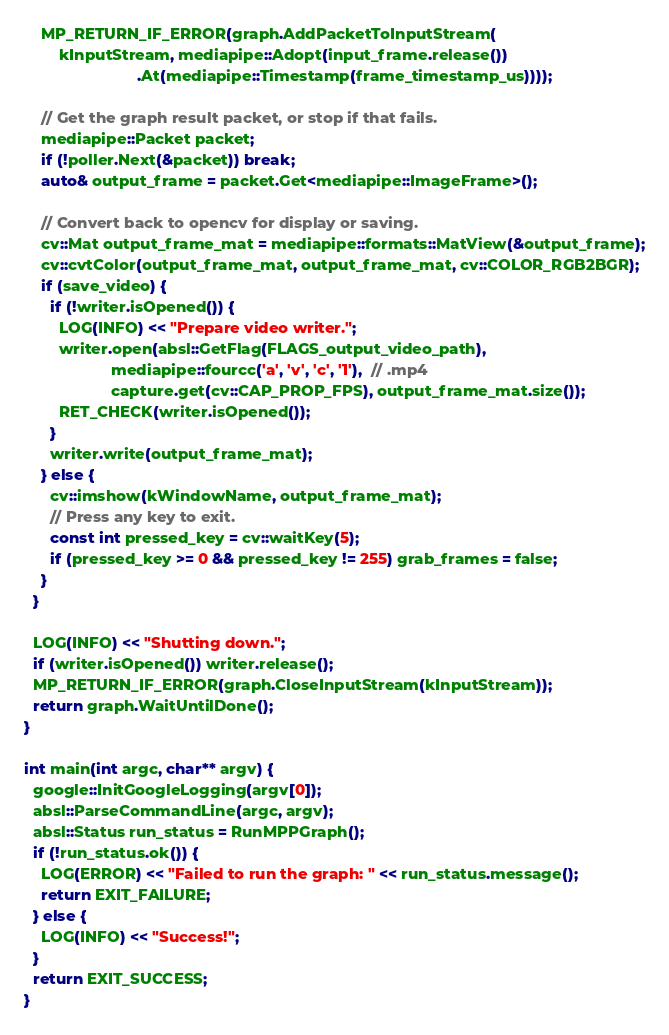<code> <loc_0><loc_0><loc_500><loc_500><_C++_>    MP_RETURN_IF_ERROR(graph.AddPacketToInputStream(
        kInputStream, mediapipe::Adopt(input_frame.release())
                          .At(mediapipe::Timestamp(frame_timestamp_us))));

    // Get the graph result packet, or stop if that fails.
    mediapipe::Packet packet;
    if (!poller.Next(&packet)) break;
    auto& output_frame = packet.Get<mediapipe::ImageFrame>();

    // Convert back to opencv for display or saving.
    cv::Mat output_frame_mat = mediapipe::formats::MatView(&output_frame);
    cv::cvtColor(output_frame_mat, output_frame_mat, cv::COLOR_RGB2BGR);
    if (save_video) {
      if (!writer.isOpened()) {
        LOG(INFO) << "Prepare video writer.";
        writer.open(absl::GetFlag(FLAGS_output_video_path),
                    mediapipe::fourcc('a', 'v', 'c', '1'),  // .mp4
                    capture.get(cv::CAP_PROP_FPS), output_frame_mat.size());
        RET_CHECK(writer.isOpened());
      }
      writer.write(output_frame_mat);
    } else {
      cv::imshow(kWindowName, output_frame_mat);
      // Press any key to exit.
      const int pressed_key = cv::waitKey(5);
      if (pressed_key >= 0 && pressed_key != 255) grab_frames = false;
    }
  }

  LOG(INFO) << "Shutting down.";
  if (writer.isOpened()) writer.release();
  MP_RETURN_IF_ERROR(graph.CloseInputStream(kInputStream));
  return graph.WaitUntilDone();
}

int main(int argc, char** argv) {
  google::InitGoogleLogging(argv[0]);
  absl::ParseCommandLine(argc, argv);
  absl::Status run_status = RunMPPGraph();
  if (!run_status.ok()) {
    LOG(ERROR) << "Failed to run the graph: " << run_status.message();
    return EXIT_FAILURE;
  } else {
    LOG(INFO) << "Success!";
  }
  return EXIT_SUCCESS;
}
</code> 